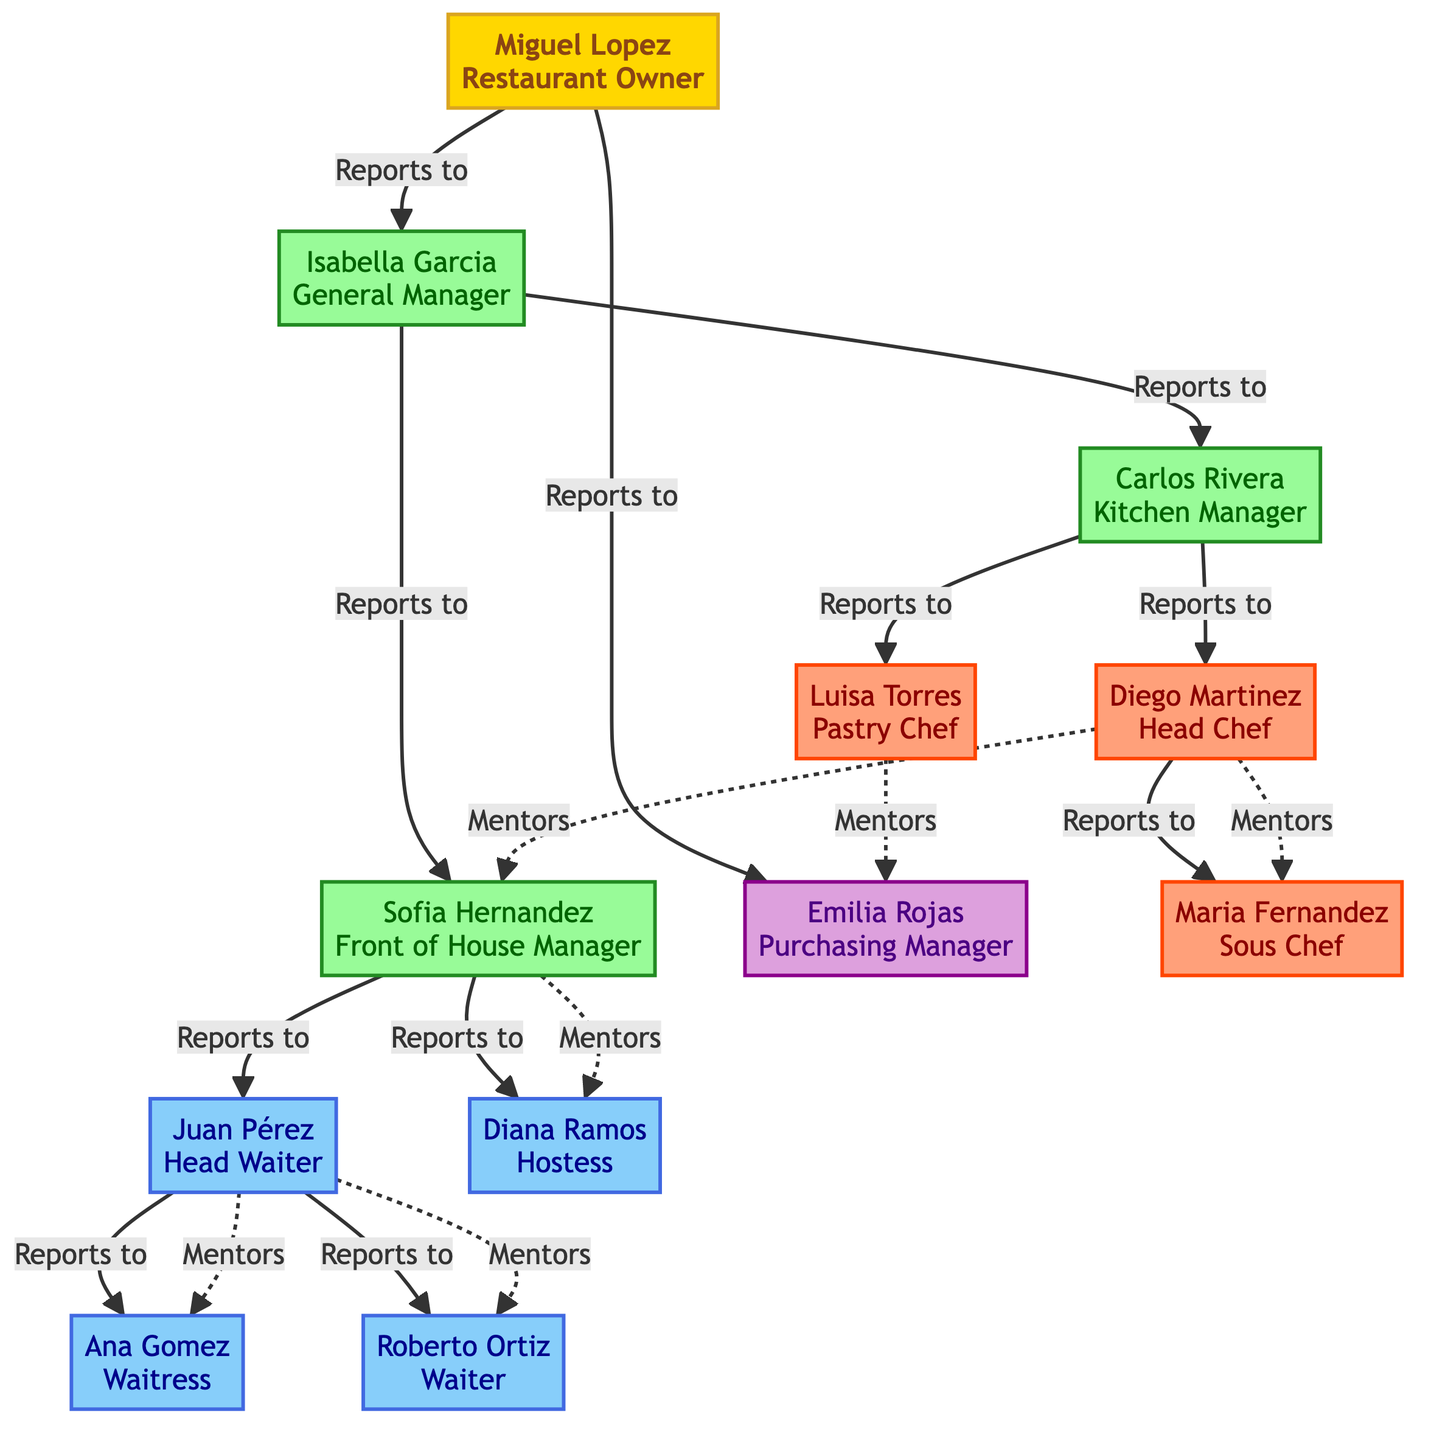What is the role of Miguel Lopez? Miguel Lopez is the owner of the restaurant, which is indicated at the top of the family tree diagram.
Answer: Restaurant Owner Who reports to Isabella Garcia? The children of Isabella Garcia in the diagram are Carlos Rivera and Sofia Hernandez, indicating they report directly to her.
Answer: Carlos Rivera, Sofia Hernandez How many children does Carlos Rivera have? In the diagram, Carlos Rivera has two children: Diego Martinez and Luisa Torres, so we count them to find the answer.
Answer: 2 What is the mentorship relationship between Diego Martinez and Maria Fernandez? According to the diagram, Maria Fernandez, as Sous Chef, is mentored by Diego Martinez, showing a direct mentorship connection between them.
Answer: Diego Martinez Which role is responsible for front of house management? The diagram mentions Sofia Hernandez as the Front of House Manager, indicating her responsibility in this area.
Answer: Front of House Manager Who does Juan Pérez mentor? Juan Pérez is shown to mentor both Ana Gomez and Roberto Ortiz, as represented in the diagram where these relationships are clearly marked.
Answer: Ana Gomez, Roberto Ortiz How many managers are reported under Miguel Lopez? There are three individuals who report directly to Miguel Lopez: Isabella Garcia, Emilia Rojas, and Carlos Rivera, so we count them to get the answer.
Answer: 3 What is the mentoring hierarchy from Sofia Hernandez? Sofia Hernandez mentors Diana Ramos, which is indicated in the diagram under her role, establishing the mentorship flow in this family tree structure.
Answer: Diana Ramos Which role has the highest number of direct reports? Carlos Rivera has the highest number of direct reports with three individuals (Diego Martinez, Luisa Torres, and Sofia Hernandez) reporting to him.
Answer: Kitchen Manager 